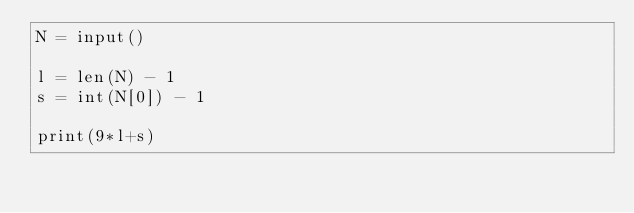<code> <loc_0><loc_0><loc_500><loc_500><_Python_>N = input()

l = len(N) - 1
s = int(N[0]) - 1

print(9*l+s)

</code> 